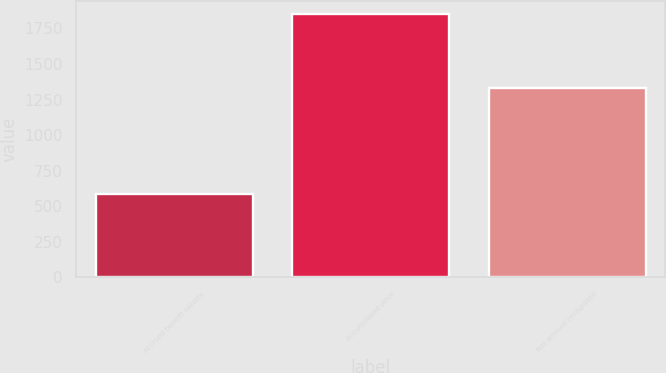<chart> <loc_0><loc_0><loc_500><loc_500><bar_chart><fcel>Accrued benefit liability<fcel>Accumulated other<fcel>Net amount recognized<nl><fcel>583<fcel>1853<fcel>1329<nl></chart> 